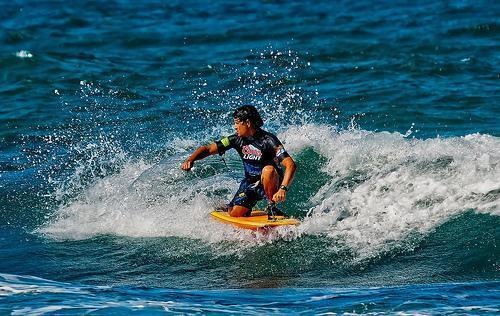How many surfers?
Give a very brief answer. 1. 